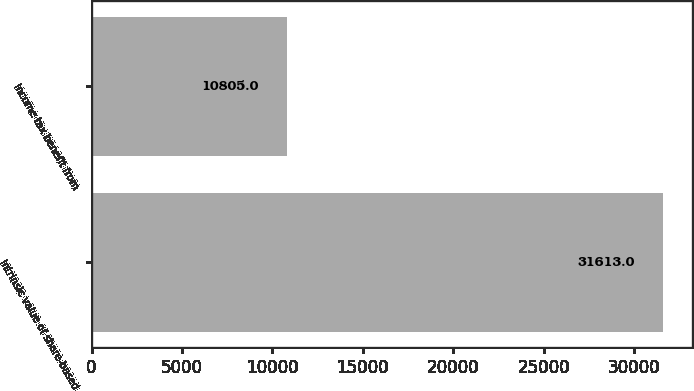Convert chart. <chart><loc_0><loc_0><loc_500><loc_500><bar_chart><fcel>Intrinsic value of share-based<fcel>Income tax benefit from<nl><fcel>31613<fcel>10805<nl></chart> 